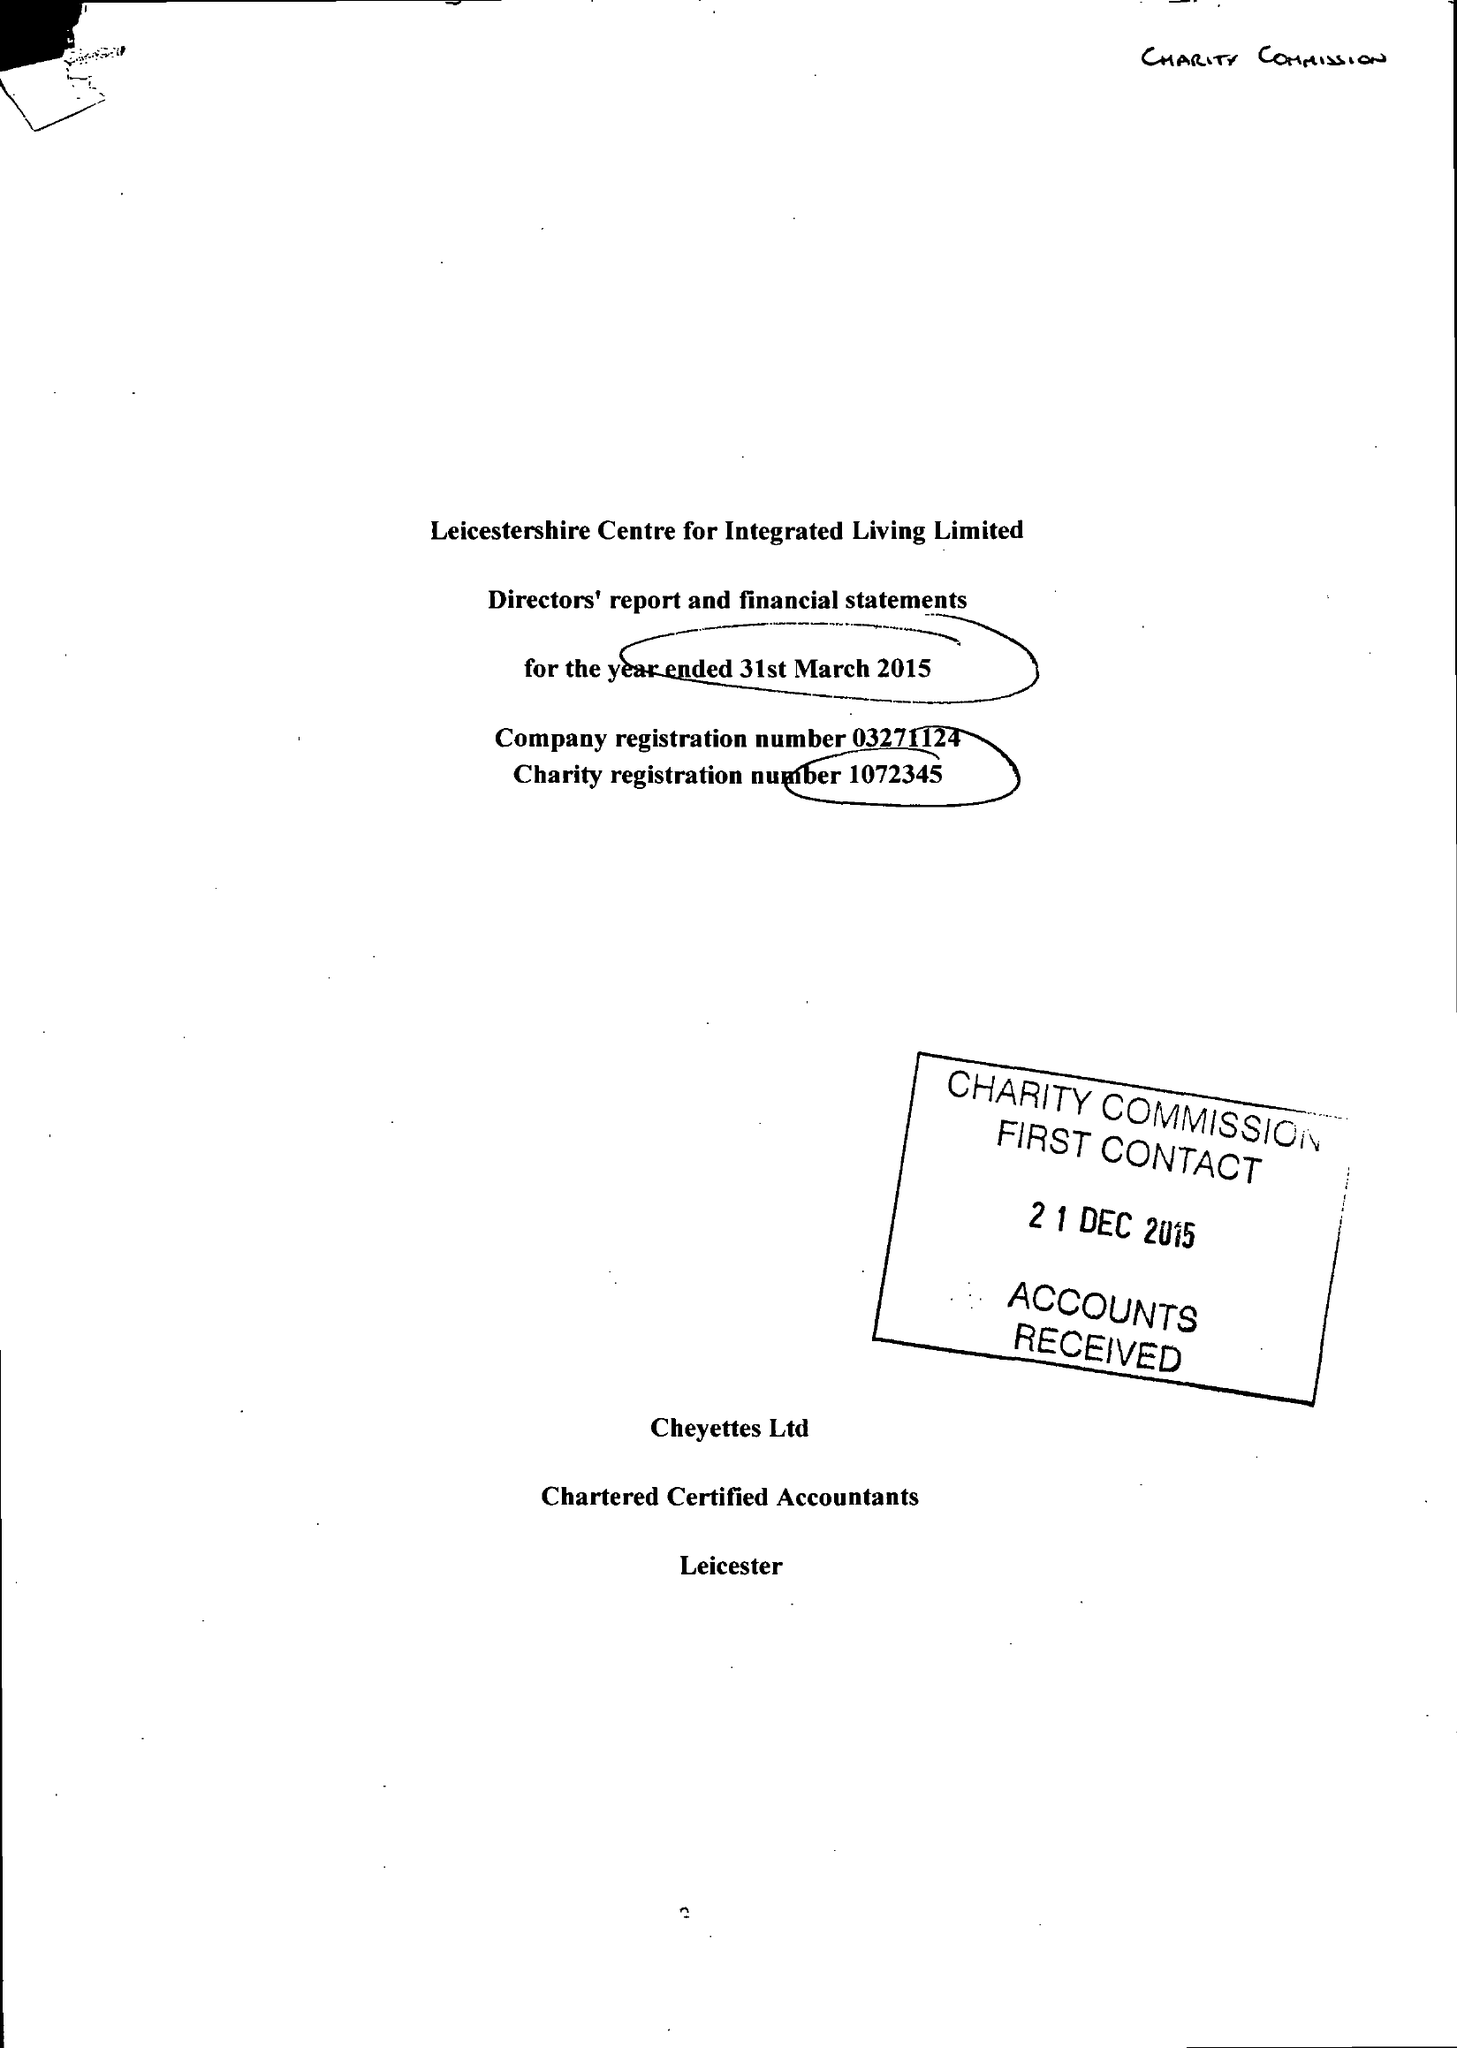What is the value for the address__street_line?
Answer the question using a single word or phrase. ANDREWES STREET 